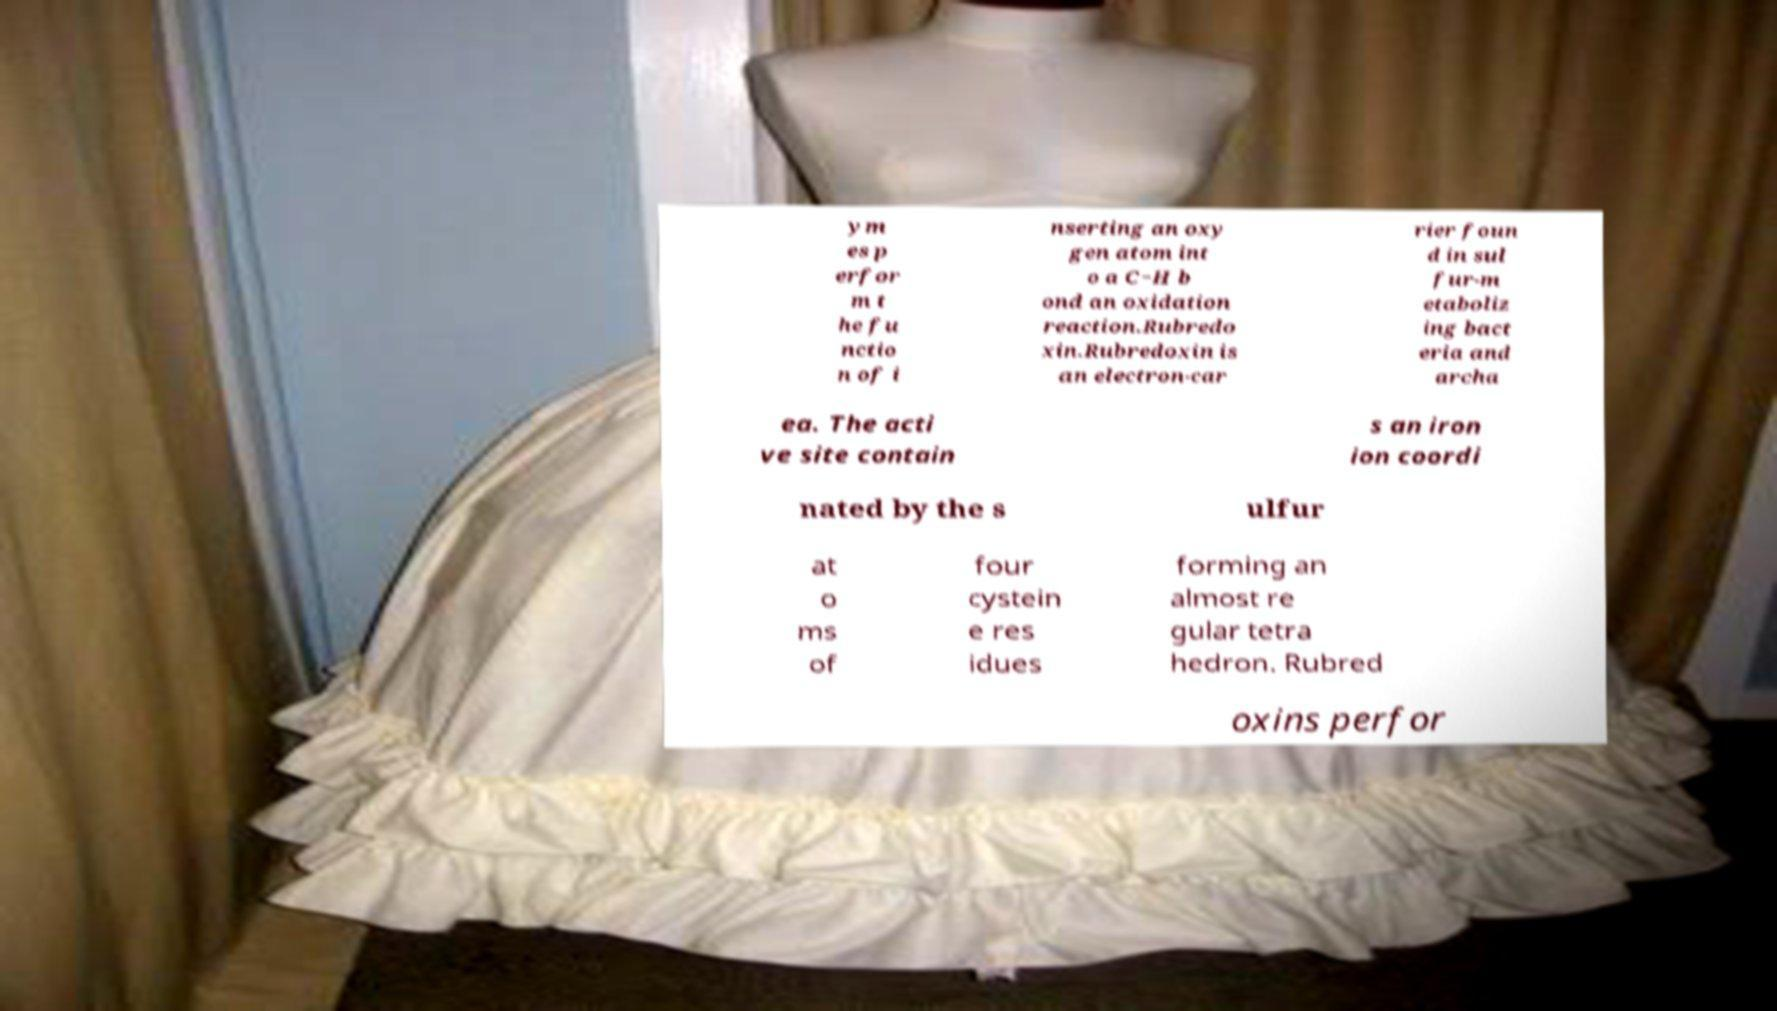There's text embedded in this image that I need extracted. Can you transcribe it verbatim? ym es p erfor m t he fu nctio n of i nserting an oxy gen atom int o a C−H b ond an oxidation reaction.Rubredo xin.Rubredoxin is an electron-car rier foun d in sul fur-m etaboliz ing bact eria and archa ea. The acti ve site contain s an iron ion coordi nated by the s ulfur at o ms of four cystein e res idues forming an almost re gular tetra hedron. Rubred oxins perfor 